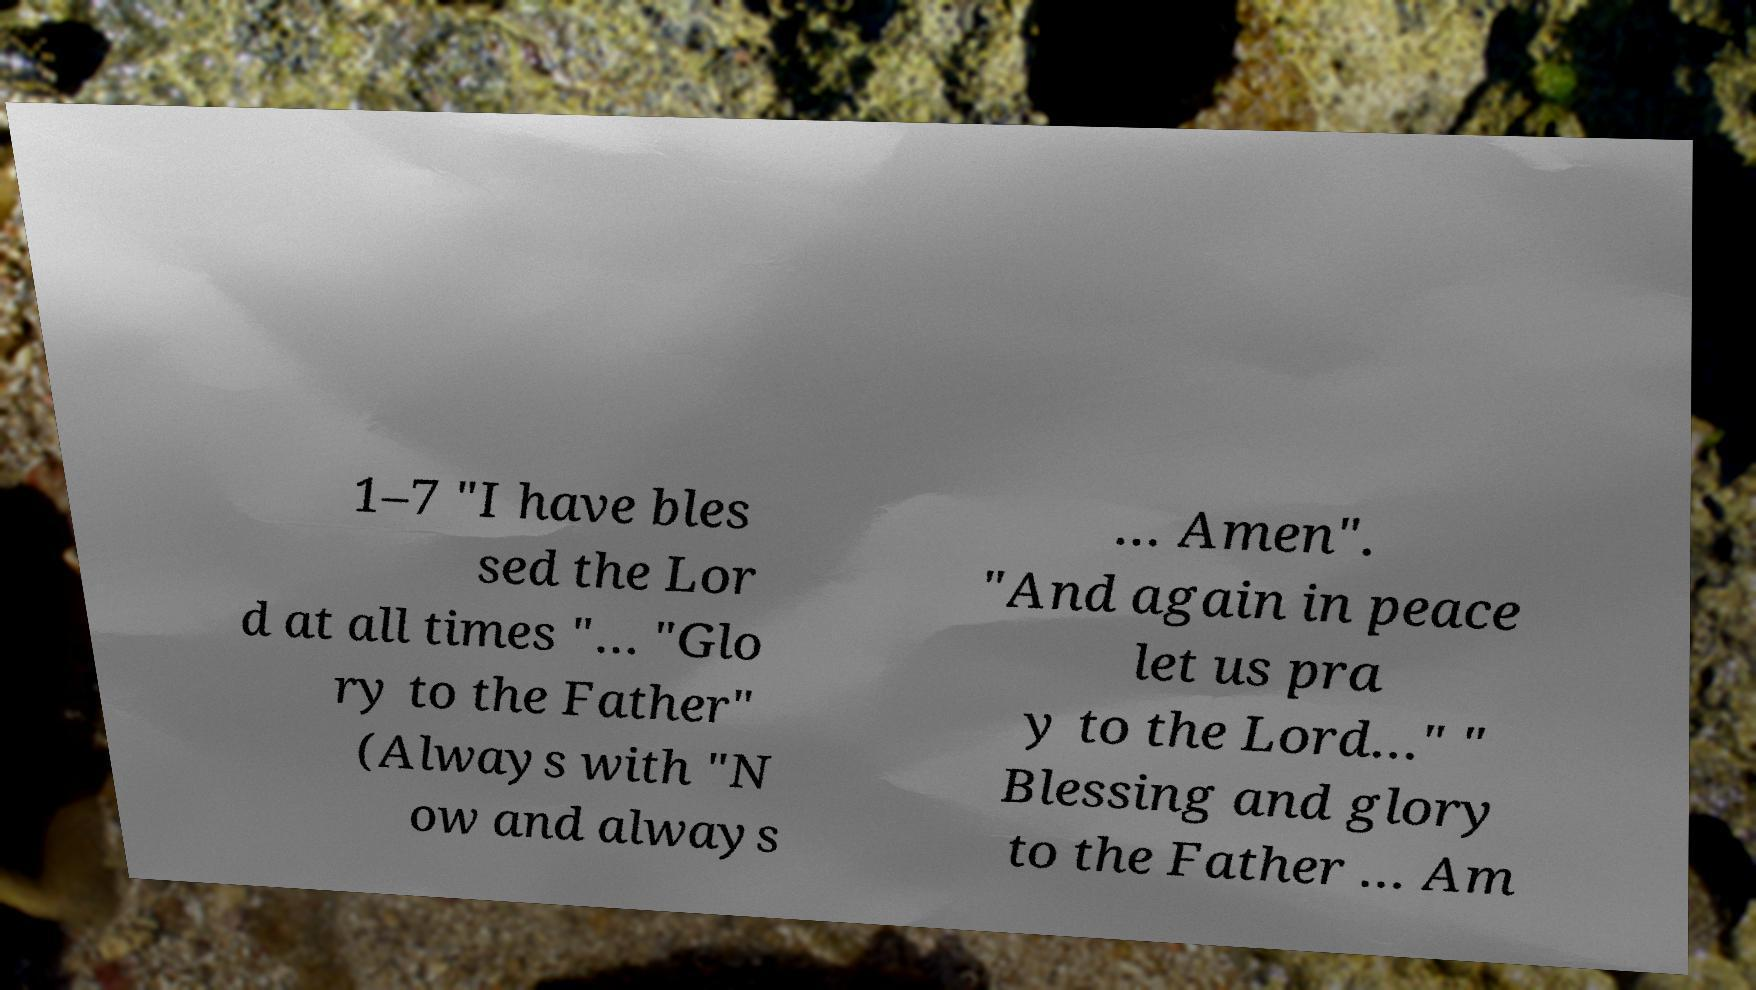There's text embedded in this image that I need extracted. Can you transcribe it verbatim? 1–7 "I have bles sed the Lor d at all times "… "Glo ry to the Father" (Always with "N ow and always … Amen". "And again in peace let us pra y to the Lord…" " Blessing and glory to the Father … Am 